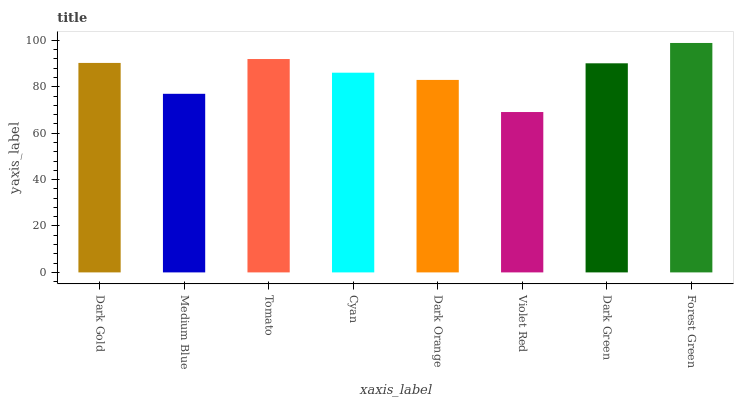Is Violet Red the minimum?
Answer yes or no. Yes. Is Forest Green the maximum?
Answer yes or no. Yes. Is Medium Blue the minimum?
Answer yes or no. No. Is Medium Blue the maximum?
Answer yes or no. No. Is Dark Gold greater than Medium Blue?
Answer yes or no. Yes. Is Medium Blue less than Dark Gold?
Answer yes or no. Yes. Is Medium Blue greater than Dark Gold?
Answer yes or no. No. Is Dark Gold less than Medium Blue?
Answer yes or no. No. Is Dark Green the high median?
Answer yes or no. Yes. Is Cyan the low median?
Answer yes or no. Yes. Is Violet Red the high median?
Answer yes or no. No. Is Dark Orange the low median?
Answer yes or no. No. 